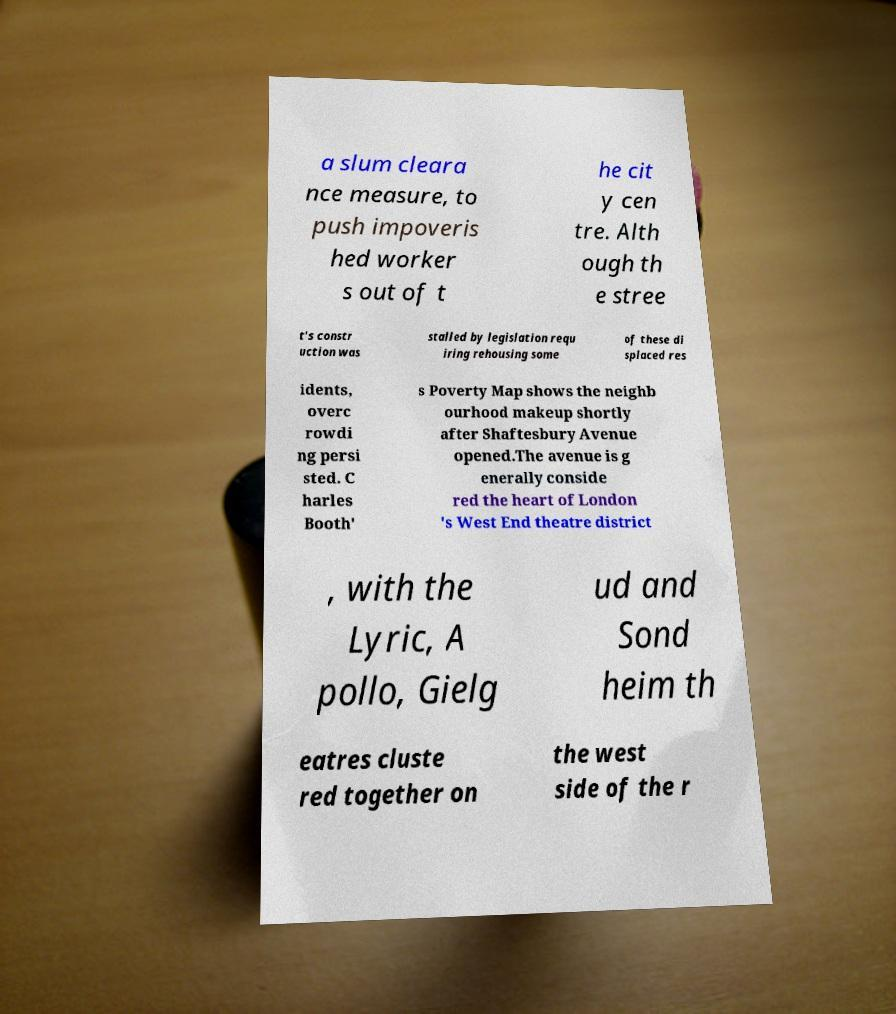Could you extract and type out the text from this image? a slum cleara nce measure, to push impoveris hed worker s out of t he cit y cen tre. Alth ough th e stree t's constr uction was stalled by legislation requ iring rehousing some of these di splaced res idents, overc rowdi ng persi sted. C harles Booth' s Poverty Map shows the neighb ourhood makeup shortly after Shaftesbury Avenue opened.The avenue is g enerally conside red the heart of London 's West End theatre district , with the Lyric, A pollo, Gielg ud and Sond heim th eatres cluste red together on the west side of the r 